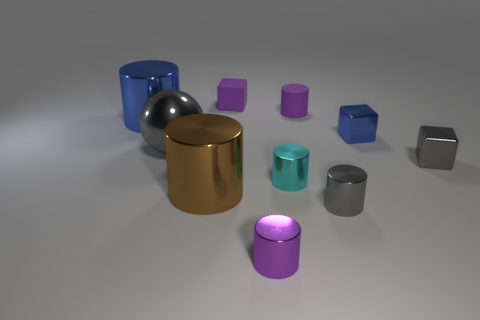There is a purple cylinder in front of the blue shiny cylinder; does it have the same size as the blue metallic cube?
Keep it short and to the point. Yes. The other big cylinder that is the same material as the big brown cylinder is what color?
Offer a terse response. Blue. How many large blue cylinders are to the right of the big blue shiny object?
Ensure brevity in your answer.  0. There is a large shiny cylinder that is in front of the gray metallic cube; is its color the same as the metal sphere that is to the right of the blue metallic cylinder?
Your answer should be compact. No. What color is the other large object that is the same shape as the brown thing?
Provide a succinct answer. Blue. Is there any other thing that has the same shape as the tiny blue shiny object?
Your answer should be compact. Yes. Is the shape of the small gray metal thing that is on the right side of the blue metallic block the same as the blue metallic object left of the tiny blue shiny block?
Your answer should be compact. No. There is a purple matte cube; does it have the same size as the purple rubber cylinder that is on the right side of the blue cylinder?
Offer a terse response. Yes. Are there more large blue shiny objects than shiny blocks?
Provide a succinct answer. No. Are the gray object on the left side of the tiny cyan cylinder and the large cylinder to the left of the brown cylinder made of the same material?
Provide a succinct answer. Yes. 